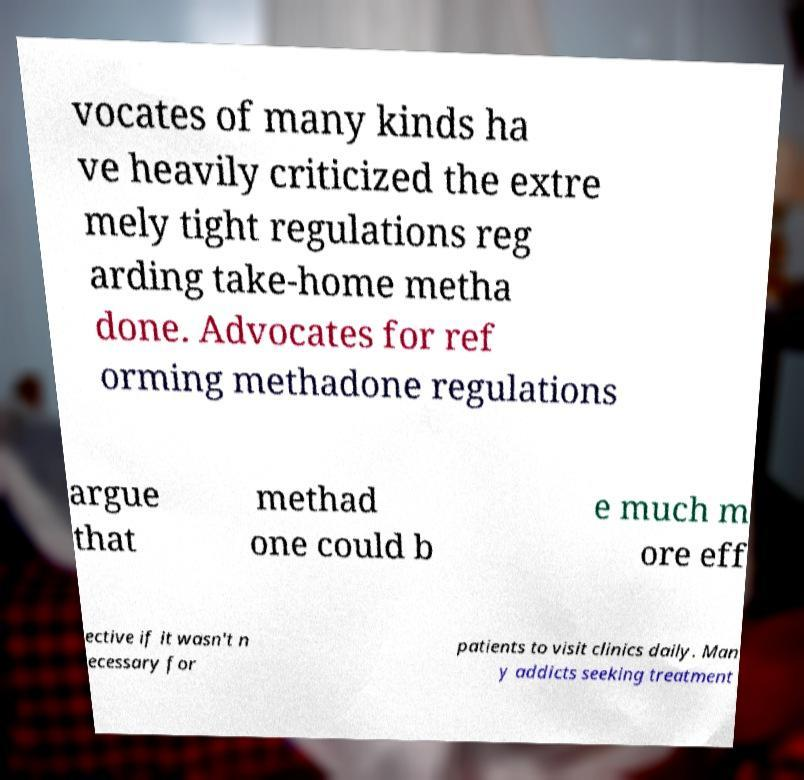Please read and relay the text visible in this image. What does it say? vocates of many kinds ha ve heavily criticized the extre mely tight regulations reg arding take-home metha done. Advocates for ref orming methadone regulations argue that methad one could b e much m ore eff ective if it wasn't n ecessary for patients to visit clinics daily. Man y addicts seeking treatment 